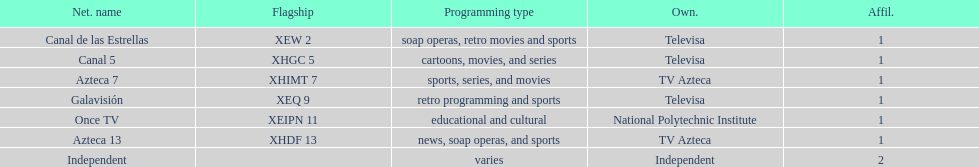Azteca 7 and azteca 13 are both owned by whom? TV Azteca. 